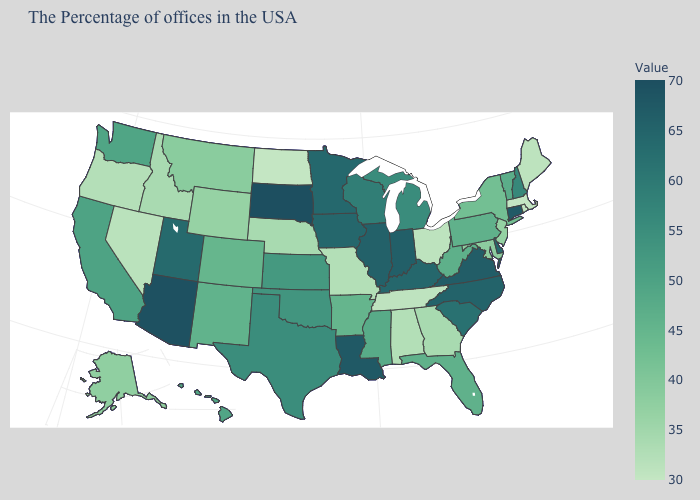Which states have the lowest value in the South?
Answer briefly. Tennessee. Which states have the highest value in the USA?
Short answer required. South Dakota. Does Utah have the highest value in the USA?
Short answer required. No. Which states have the lowest value in the West?
Quick response, please. Nevada. Does the map have missing data?
Be succinct. No. 